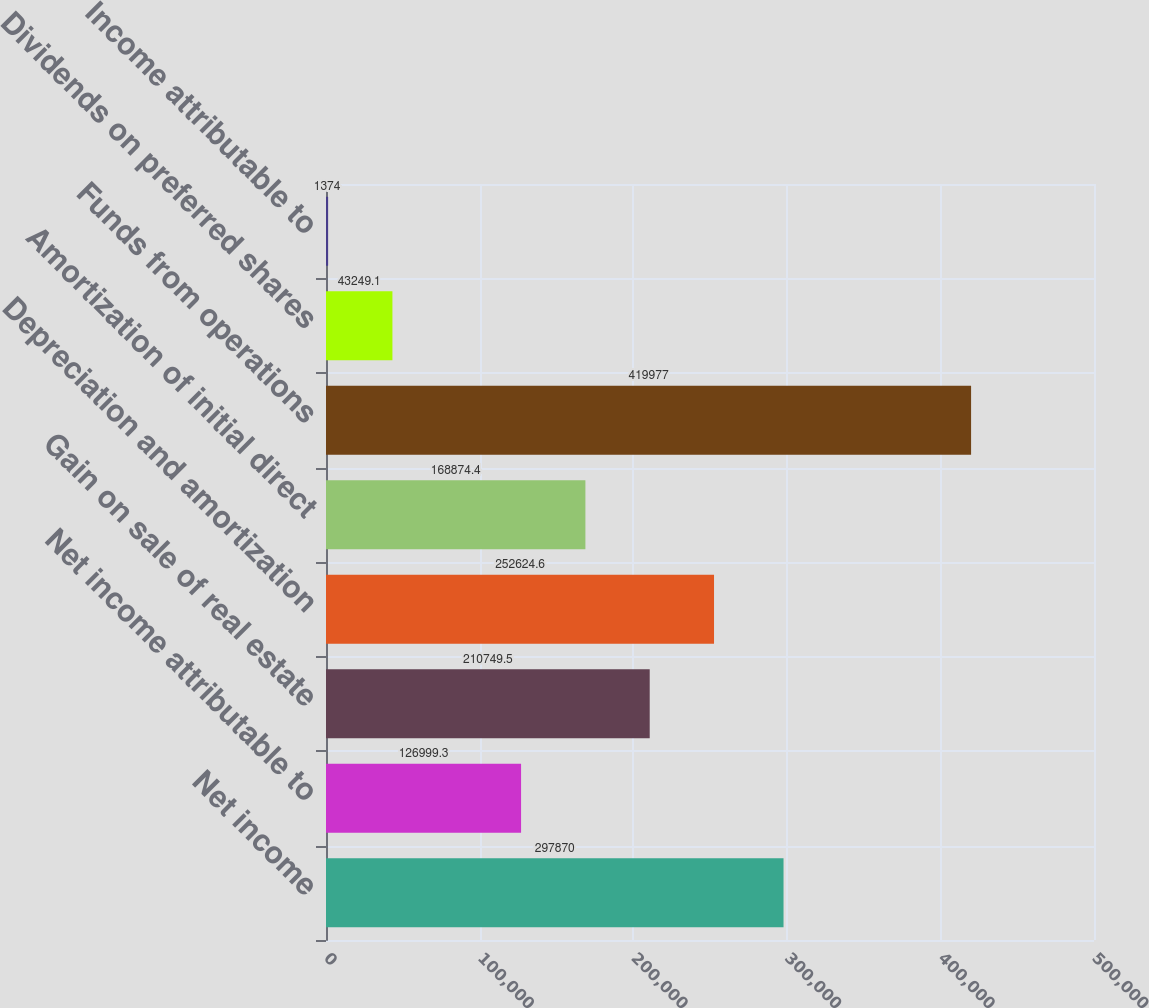Convert chart to OTSL. <chart><loc_0><loc_0><loc_500><loc_500><bar_chart><fcel>Net income<fcel>Net income attributable to<fcel>Gain on sale of real estate<fcel>Depreciation and amortization<fcel>Amortization of initial direct<fcel>Funds from operations<fcel>Dividends on preferred shares<fcel>Income attributable to<nl><fcel>297870<fcel>126999<fcel>210750<fcel>252625<fcel>168874<fcel>419977<fcel>43249.1<fcel>1374<nl></chart> 